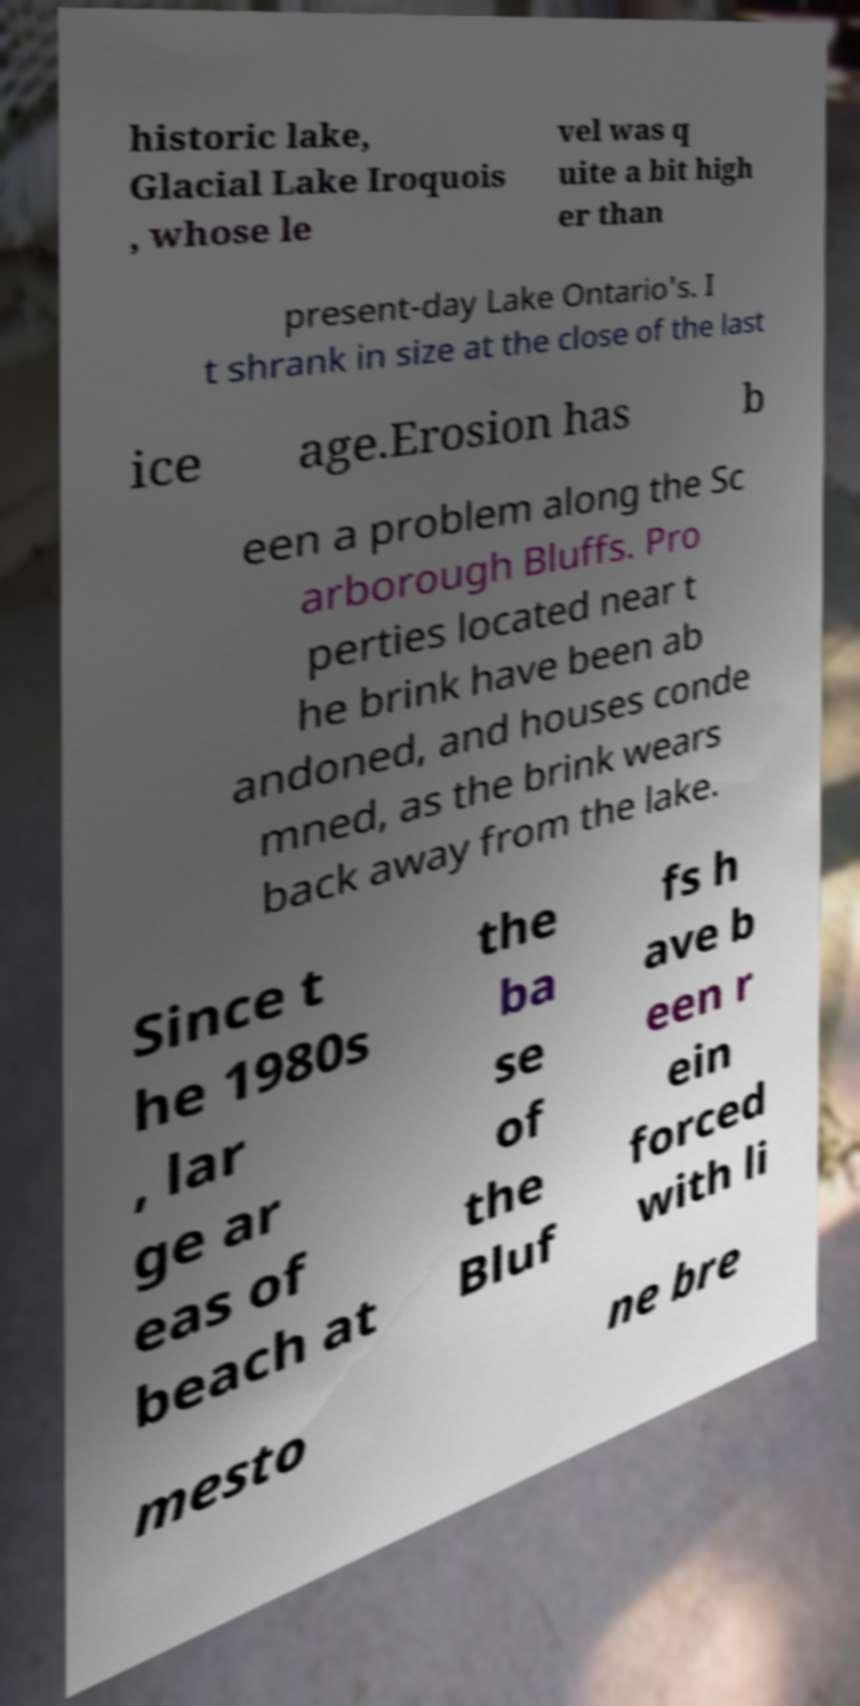What messages or text are displayed in this image? I need them in a readable, typed format. historic lake, Glacial Lake Iroquois , whose le vel was q uite a bit high er than present-day Lake Ontario's. I t shrank in size at the close of the last ice age.Erosion has b een a problem along the Sc arborough Bluffs. Pro perties located near t he brink have been ab andoned, and houses conde mned, as the brink wears back away from the lake. Since t he 1980s , lar ge ar eas of beach at the ba se of the Bluf fs h ave b een r ein forced with li mesto ne bre 